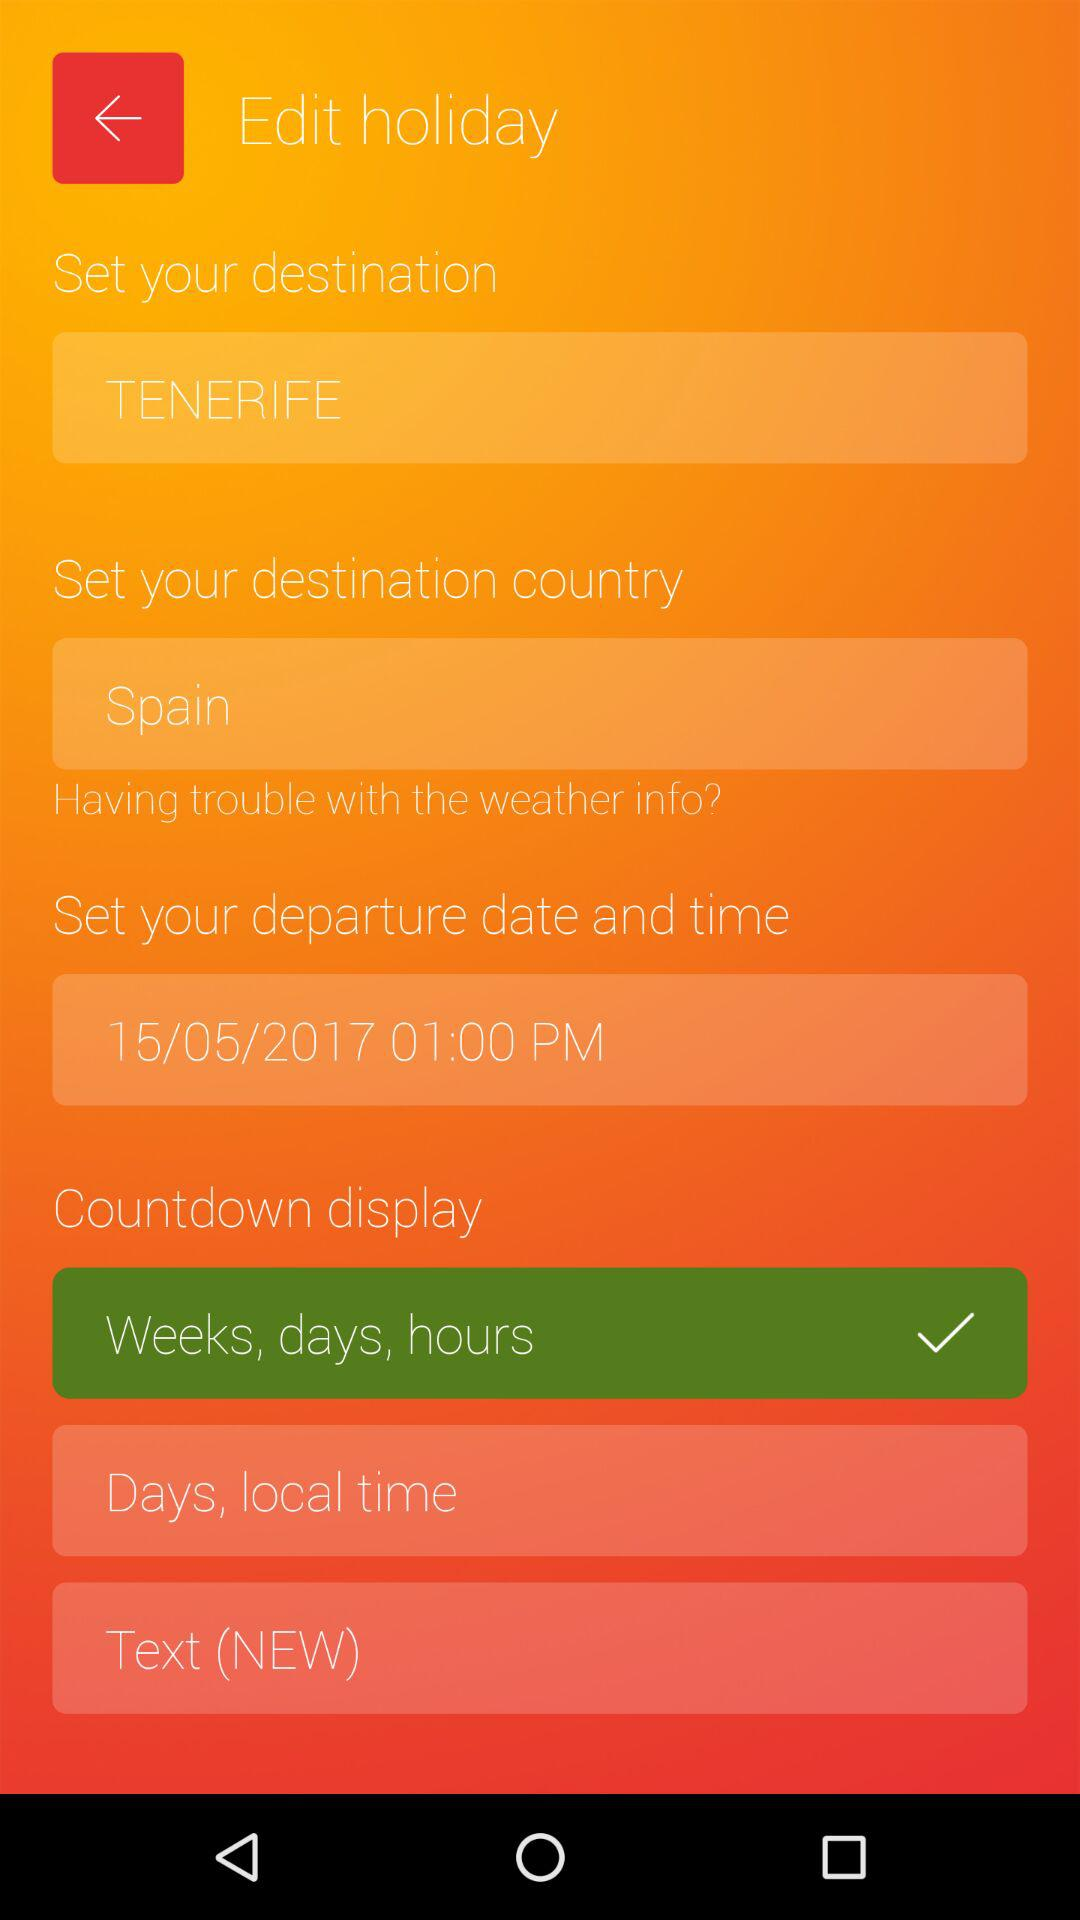How many text inputs have a text value of 'TENERIFE'?
Answer the question using a single word or phrase. 1 